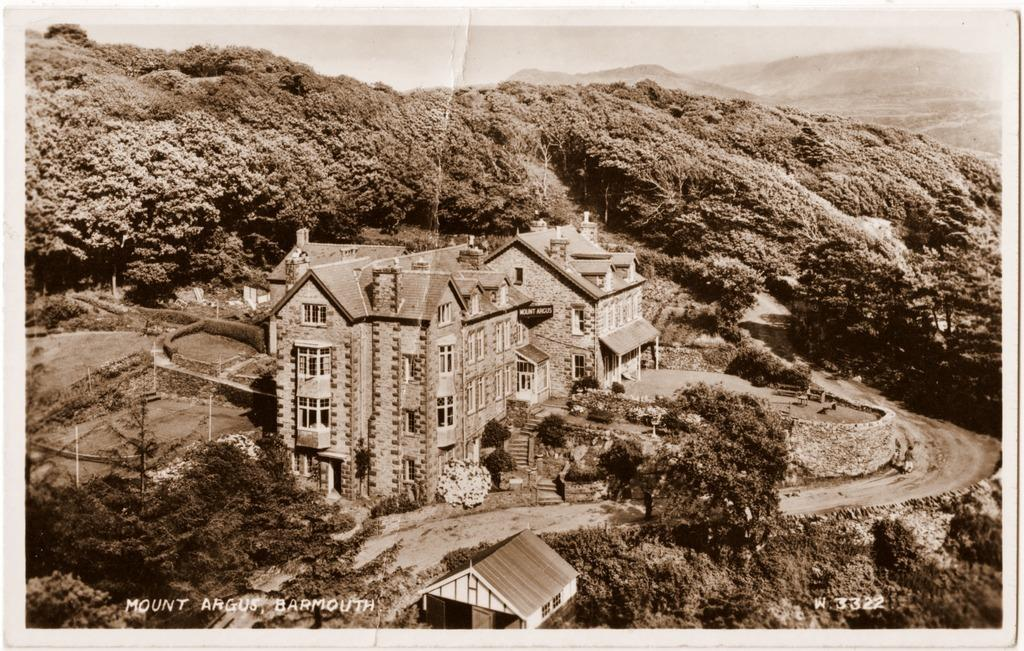What type of landscape is depicted in the image? The image features hills, trees, and water, suggesting a natural landscape. Are there any man-made structures visible in the image? Yes, there are buildings and poles visible in the image. What might be used for walking or traveling in the image? There is a pathway in the image that can be used for walking or traveling. Where is the house located in the image? The house is located at the bottom portion of the image. What is the water source in the image? There is water visible in the image, but it is not clear if it is a river, lake, or other water source. What type of leather is visible on the seashore in the image? There is no leather or seashore present in the image. Can you tell me how many fathers are visible in the image? There is no reference to a father or any people in the image. 